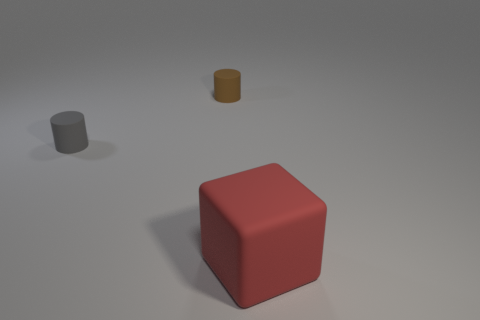Add 1 tiny rubber cylinders. How many objects exist? 4 Subtract all cylinders. How many objects are left? 1 Subtract 0 blue blocks. How many objects are left? 3 Subtract all large red matte things. Subtract all brown things. How many objects are left? 1 Add 1 gray matte things. How many gray matte things are left? 2 Add 3 cylinders. How many cylinders exist? 5 